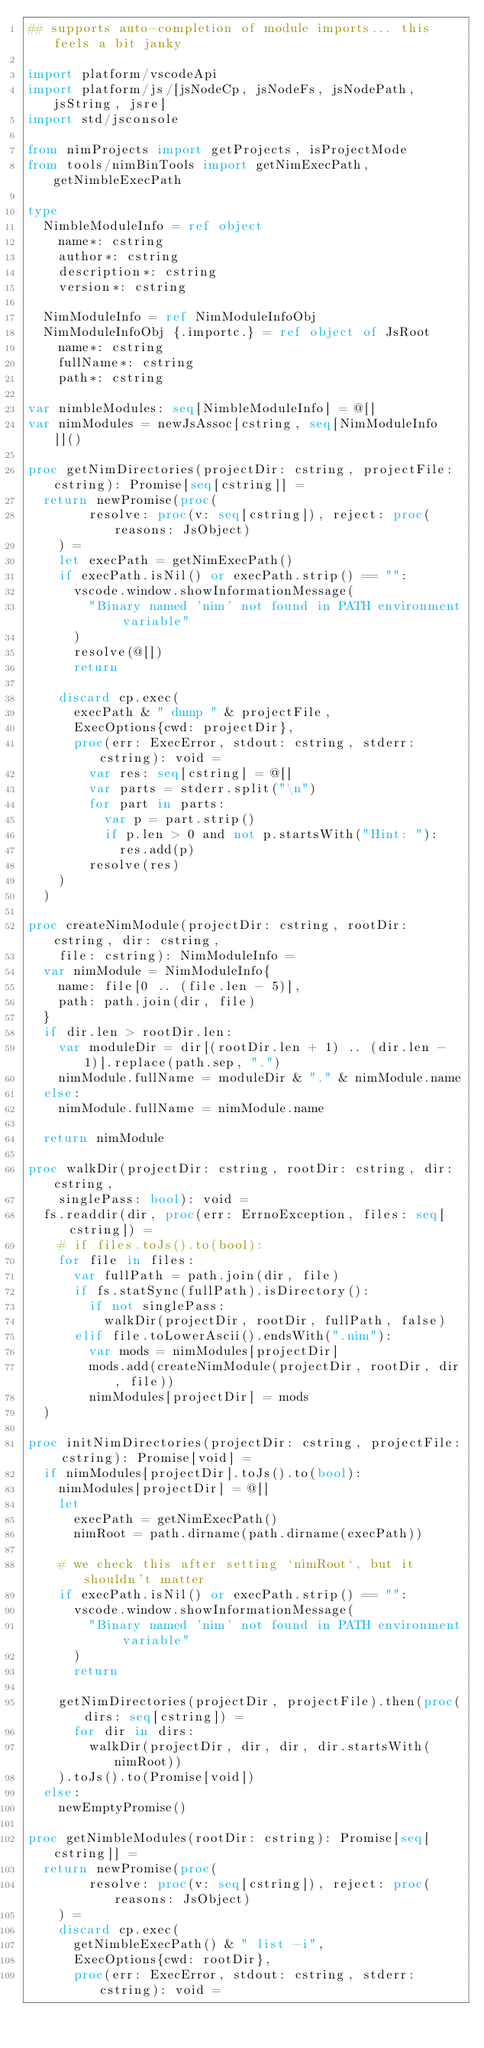<code> <loc_0><loc_0><loc_500><loc_500><_Nim_>## supports auto-completion of module imports... this feels a bit janky

import platform/vscodeApi
import platform/js/[jsNodeCp, jsNodeFs, jsNodePath, jsString, jsre]
import std/jsconsole

from nimProjects import getProjects, isProjectMode
from tools/nimBinTools import getNimExecPath, getNimbleExecPath

type
  NimbleModuleInfo = ref object
    name*: cstring
    author*: cstring
    description*: cstring
    version*: cstring

  NimModuleInfo = ref NimModuleInfoObj
  NimModuleInfoObj {.importc.} = ref object of JsRoot
    name*: cstring
    fullName*: cstring
    path*: cstring

var nimbleModules: seq[NimbleModuleInfo] = @[]
var nimModules = newJsAssoc[cstring, seq[NimModuleInfo]]()

proc getNimDirectories(projectDir: cstring, projectFile: cstring): Promise[seq[cstring]] =
  return newPromise(proc(
        resolve: proc(v: seq[cstring]), reject: proc(reasons: JsObject)
    ) =
    let execPath = getNimExecPath()
    if execPath.isNil() or execPath.strip() == "":
      vscode.window.showInformationMessage(
        "Binary named 'nim' not found in PATH environment variable"
      )
      resolve(@[])
      return

    discard cp.exec(
      execPath & " dump " & projectFile,
      ExecOptions{cwd: projectDir},
      proc(err: ExecError, stdout: cstring, stderr: cstring): void =
        var res: seq[cstring] = @[]
        var parts = stderr.split("\n")
        for part in parts:
          var p = part.strip()
          if p.len > 0 and not p.startsWith("Hint: "):
            res.add(p)
        resolve(res)
    )
  )

proc createNimModule(projectDir: cstring, rootDir: cstring, dir: cstring,
    file: cstring): NimModuleInfo =
  var nimModule = NimModuleInfo{
    name: file[0 .. (file.len - 5)],
    path: path.join(dir, file)
  }
  if dir.len > rootDir.len:
    var moduleDir = dir[(rootDir.len + 1) .. (dir.len - 1)].replace(path.sep, ".")
    nimModule.fullName = moduleDir & "." & nimModule.name
  else:
    nimModule.fullName = nimModule.name

  return nimModule

proc walkDir(projectDir: cstring, rootDir: cstring, dir: cstring,
    singlePass: bool): void =
  fs.readdir(dir, proc(err: ErrnoException, files: seq[cstring]) =
    # if files.toJs().to(bool):
    for file in files:
      var fullPath = path.join(dir, file)
      if fs.statSync(fullPath).isDirectory():
        if not singlePass:
          walkDir(projectDir, rootDir, fullPath, false)
      elif file.toLowerAscii().endsWith(".nim"):
        var mods = nimModules[projectDir]
        mods.add(createNimModule(projectDir, rootDir, dir, file))
        nimModules[projectDir] = mods
  )

proc initNimDirectories(projectDir: cstring, projectFile: cstring): Promise[void] =
  if nimModules[projectDir].toJs().to(bool):
    nimModules[projectDir] = @[]
    let
      execPath = getNimExecPath()
      nimRoot = path.dirname(path.dirname(execPath))

    # we check this after setting `nimRoot`, but it shouldn't matter
    if execPath.isNil() or execPath.strip() == "":
      vscode.window.showInformationMessage(
        "Binary named 'nim' not found in PATH environment variable"
      )
      return

    getNimDirectories(projectDir, projectFile).then(proc(dirs: seq[cstring]) =
      for dir in dirs:
        walkDir(projectDir, dir, dir, dir.startsWith(nimRoot))
    ).toJs().to(Promise[void])
  else:
    newEmptyPromise()

proc getNimbleModules(rootDir: cstring): Promise[seq[cstring]] =
  return newPromise(proc(
        resolve: proc(v: seq[cstring]), reject: proc(reasons: JsObject)
    ) =
    discard cp.exec(
      getNimbleExecPath() & " list -i",
      ExecOptions{cwd: rootDir},
      proc(err: ExecError, stdout: cstring, stderr: cstring): void =</code> 